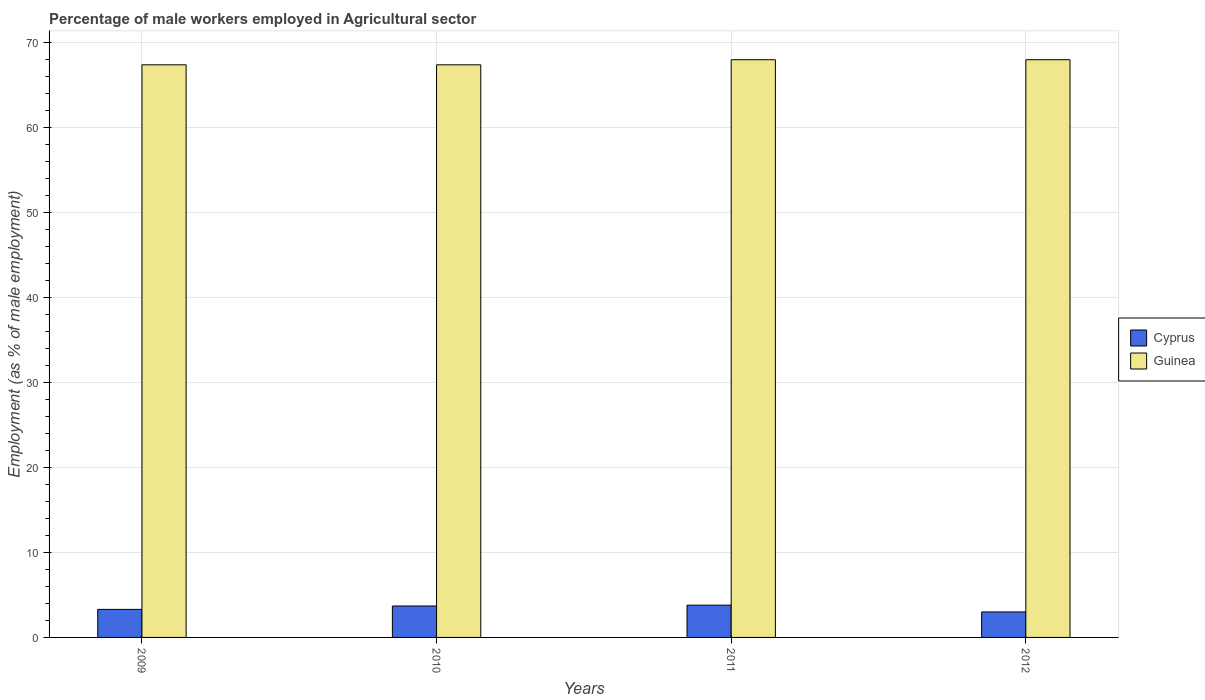How many different coloured bars are there?
Make the answer very short. 2. Are the number of bars on each tick of the X-axis equal?
Your response must be concise. Yes. What is the label of the 2nd group of bars from the left?
Make the answer very short. 2010. In how many cases, is the number of bars for a given year not equal to the number of legend labels?
Give a very brief answer. 0. What is the percentage of male workers employed in Agricultural sector in Cyprus in 2010?
Your answer should be compact. 3.7. Across all years, what is the maximum percentage of male workers employed in Agricultural sector in Cyprus?
Keep it short and to the point. 3.8. In which year was the percentage of male workers employed in Agricultural sector in Cyprus maximum?
Your answer should be compact. 2011. What is the total percentage of male workers employed in Agricultural sector in Cyprus in the graph?
Provide a succinct answer. 13.8. What is the difference between the percentage of male workers employed in Agricultural sector in Guinea in 2010 and that in 2011?
Provide a succinct answer. -0.6. What is the difference between the percentage of male workers employed in Agricultural sector in Cyprus in 2011 and the percentage of male workers employed in Agricultural sector in Guinea in 2010?
Offer a very short reply. -63.6. What is the average percentage of male workers employed in Agricultural sector in Guinea per year?
Your response must be concise. 67.7. In the year 2009, what is the difference between the percentage of male workers employed in Agricultural sector in Guinea and percentage of male workers employed in Agricultural sector in Cyprus?
Offer a terse response. 64.1. Is the percentage of male workers employed in Agricultural sector in Guinea in 2009 less than that in 2011?
Your answer should be very brief. Yes. What is the difference between the highest and the second highest percentage of male workers employed in Agricultural sector in Cyprus?
Provide a succinct answer. 0.1. What is the difference between the highest and the lowest percentage of male workers employed in Agricultural sector in Cyprus?
Your answer should be very brief. 0.8. In how many years, is the percentage of male workers employed in Agricultural sector in Cyprus greater than the average percentage of male workers employed in Agricultural sector in Cyprus taken over all years?
Offer a very short reply. 2. What does the 2nd bar from the left in 2010 represents?
Your answer should be compact. Guinea. What does the 1st bar from the right in 2009 represents?
Ensure brevity in your answer.  Guinea. How many years are there in the graph?
Your response must be concise. 4. Are the values on the major ticks of Y-axis written in scientific E-notation?
Your answer should be compact. No. Does the graph contain any zero values?
Offer a terse response. No. Where does the legend appear in the graph?
Your response must be concise. Center right. What is the title of the graph?
Ensure brevity in your answer.  Percentage of male workers employed in Agricultural sector. Does "Monaco" appear as one of the legend labels in the graph?
Provide a succinct answer. No. What is the label or title of the Y-axis?
Provide a short and direct response. Employment (as % of male employment). What is the Employment (as % of male employment) in Cyprus in 2009?
Offer a terse response. 3.3. What is the Employment (as % of male employment) in Guinea in 2009?
Your answer should be very brief. 67.4. What is the Employment (as % of male employment) in Cyprus in 2010?
Provide a succinct answer. 3.7. What is the Employment (as % of male employment) in Guinea in 2010?
Your answer should be compact. 67.4. What is the Employment (as % of male employment) of Cyprus in 2011?
Provide a short and direct response. 3.8. What is the Employment (as % of male employment) in Guinea in 2011?
Offer a very short reply. 68. What is the Employment (as % of male employment) in Cyprus in 2012?
Your answer should be compact. 3. What is the Employment (as % of male employment) of Guinea in 2012?
Give a very brief answer. 68. Across all years, what is the maximum Employment (as % of male employment) in Cyprus?
Keep it short and to the point. 3.8. Across all years, what is the minimum Employment (as % of male employment) in Cyprus?
Ensure brevity in your answer.  3. Across all years, what is the minimum Employment (as % of male employment) of Guinea?
Make the answer very short. 67.4. What is the total Employment (as % of male employment) of Guinea in the graph?
Give a very brief answer. 270.8. What is the difference between the Employment (as % of male employment) in Cyprus in 2009 and that in 2010?
Provide a short and direct response. -0.4. What is the difference between the Employment (as % of male employment) in Cyprus in 2009 and that in 2012?
Offer a very short reply. 0.3. What is the difference between the Employment (as % of male employment) of Guinea in 2010 and that in 2011?
Your answer should be very brief. -0.6. What is the difference between the Employment (as % of male employment) of Guinea in 2010 and that in 2012?
Offer a terse response. -0.6. What is the difference between the Employment (as % of male employment) in Cyprus in 2011 and that in 2012?
Your answer should be very brief. 0.8. What is the difference between the Employment (as % of male employment) in Cyprus in 2009 and the Employment (as % of male employment) in Guinea in 2010?
Your answer should be very brief. -64.1. What is the difference between the Employment (as % of male employment) of Cyprus in 2009 and the Employment (as % of male employment) of Guinea in 2011?
Provide a succinct answer. -64.7. What is the difference between the Employment (as % of male employment) in Cyprus in 2009 and the Employment (as % of male employment) in Guinea in 2012?
Ensure brevity in your answer.  -64.7. What is the difference between the Employment (as % of male employment) in Cyprus in 2010 and the Employment (as % of male employment) in Guinea in 2011?
Give a very brief answer. -64.3. What is the difference between the Employment (as % of male employment) in Cyprus in 2010 and the Employment (as % of male employment) in Guinea in 2012?
Keep it short and to the point. -64.3. What is the difference between the Employment (as % of male employment) in Cyprus in 2011 and the Employment (as % of male employment) in Guinea in 2012?
Give a very brief answer. -64.2. What is the average Employment (as % of male employment) of Cyprus per year?
Your answer should be very brief. 3.45. What is the average Employment (as % of male employment) in Guinea per year?
Offer a terse response. 67.7. In the year 2009, what is the difference between the Employment (as % of male employment) of Cyprus and Employment (as % of male employment) of Guinea?
Your answer should be compact. -64.1. In the year 2010, what is the difference between the Employment (as % of male employment) in Cyprus and Employment (as % of male employment) in Guinea?
Your answer should be very brief. -63.7. In the year 2011, what is the difference between the Employment (as % of male employment) of Cyprus and Employment (as % of male employment) of Guinea?
Your answer should be very brief. -64.2. In the year 2012, what is the difference between the Employment (as % of male employment) in Cyprus and Employment (as % of male employment) in Guinea?
Make the answer very short. -65. What is the ratio of the Employment (as % of male employment) in Cyprus in 2009 to that in 2010?
Offer a very short reply. 0.89. What is the ratio of the Employment (as % of male employment) in Guinea in 2009 to that in 2010?
Provide a short and direct response. 1. What is the ratio of the Employment (as % of male employment) in Cyprus in 2009 to that in 2011?
Make the answer very short. 0.87. What is the ratio of the Employment (as % of male employment) in Cyprus in 2010 to that in 2011?
Provide a short and direct response. 0.97. What is the ratio of the Employment (as % of male employment) in Guinea in 2010 to that in 2011?
Your answer should be very brief. 0.99. What is the ratio of the Employment (as % of male employment) in Cyprus in 2010 to that in 2012?
Give a very brief answer. 1.23. What is the ratio of the Employment (as % of male employment) of Guinea in 2010 to that in 2012?
Make the answer very short. 0.99. What is the ratio of the Employment (as % of male employment) of Cyprus in 2011 to that in 2012?
Provide a short and direct response. 1.27. What is the difference between the highest and the second highest Employment (as % of male employment) of Cyprus?
Your answer should be compact. 0.1. What is the difference between the highest and the second highest Employment (as % of male employment) in Guinea?
Give a very brief answer. 0. What is the difference between the highest and the lowest Employment (as % of male employment) of Guinea?
Ensure brevity in your answer.  0.6. 